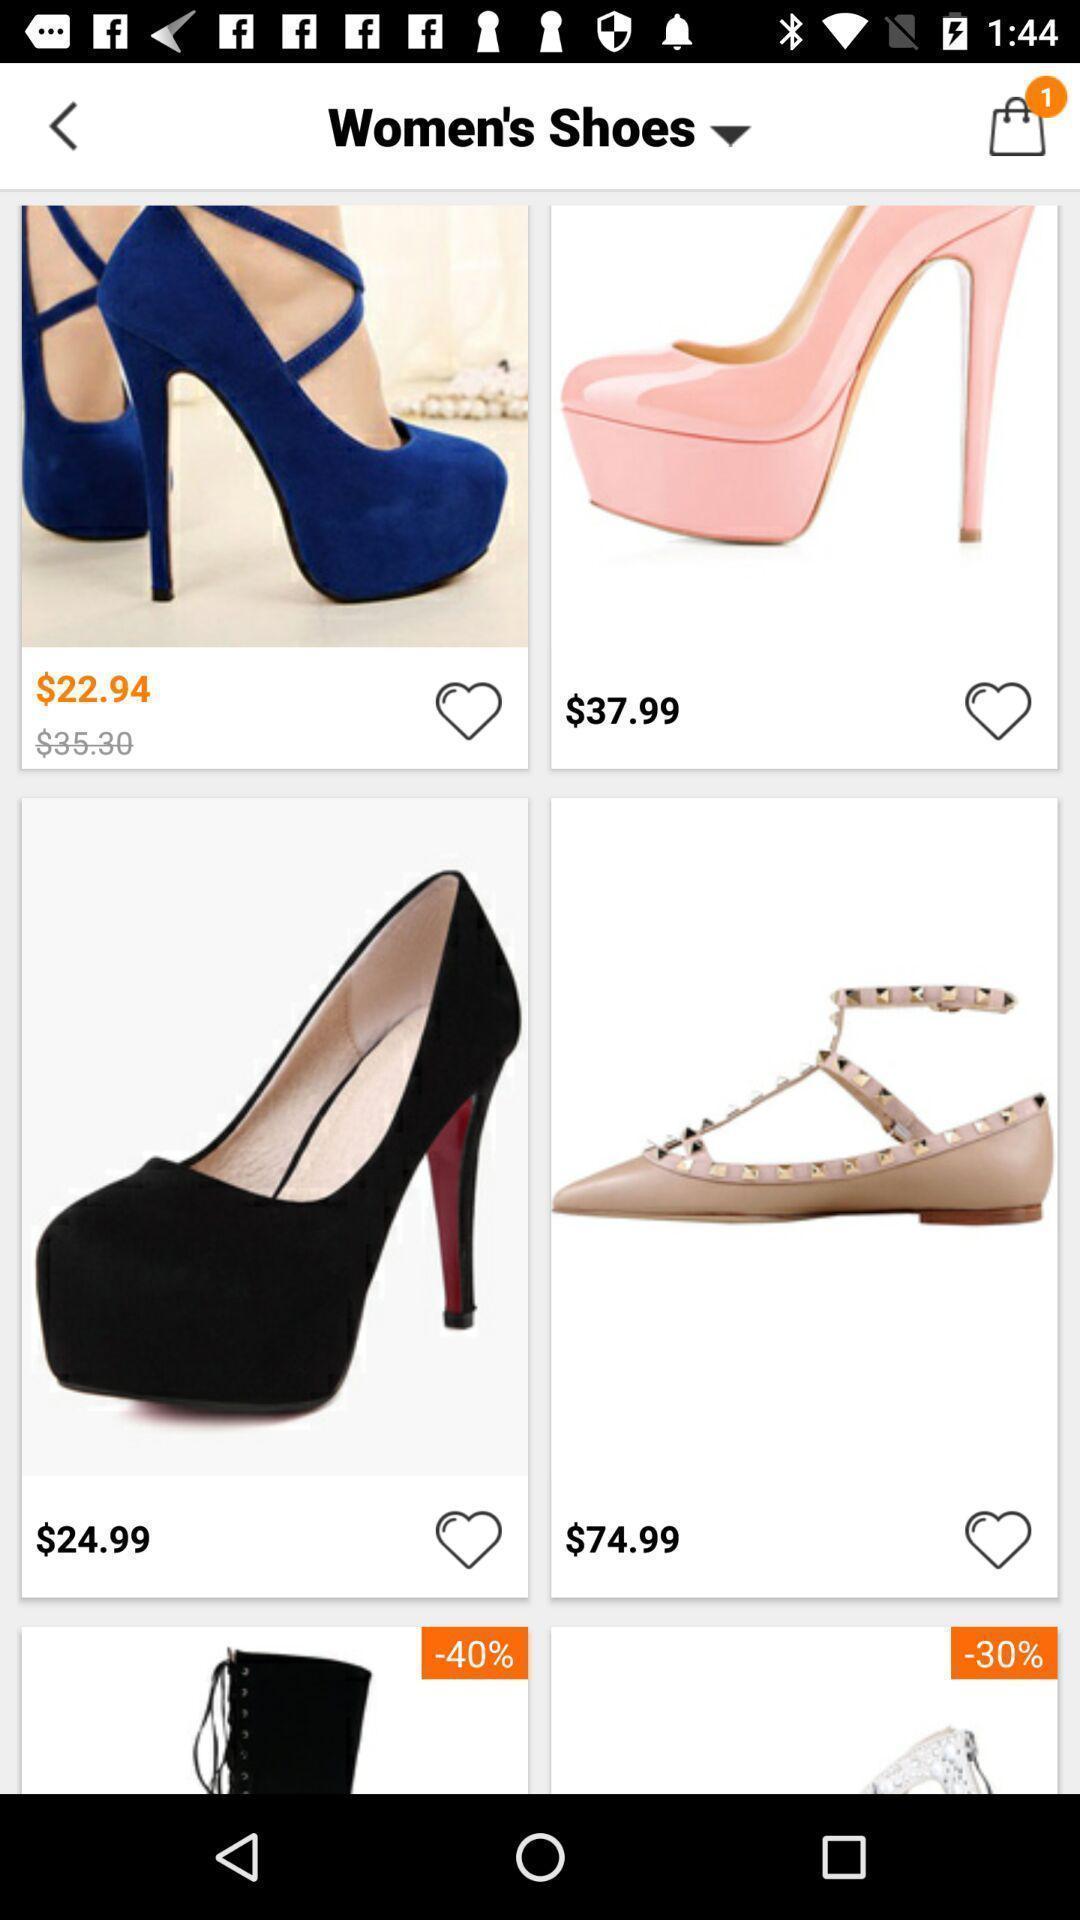What is the overall content of this screenshot? Screen displaying multiple products images with price. 